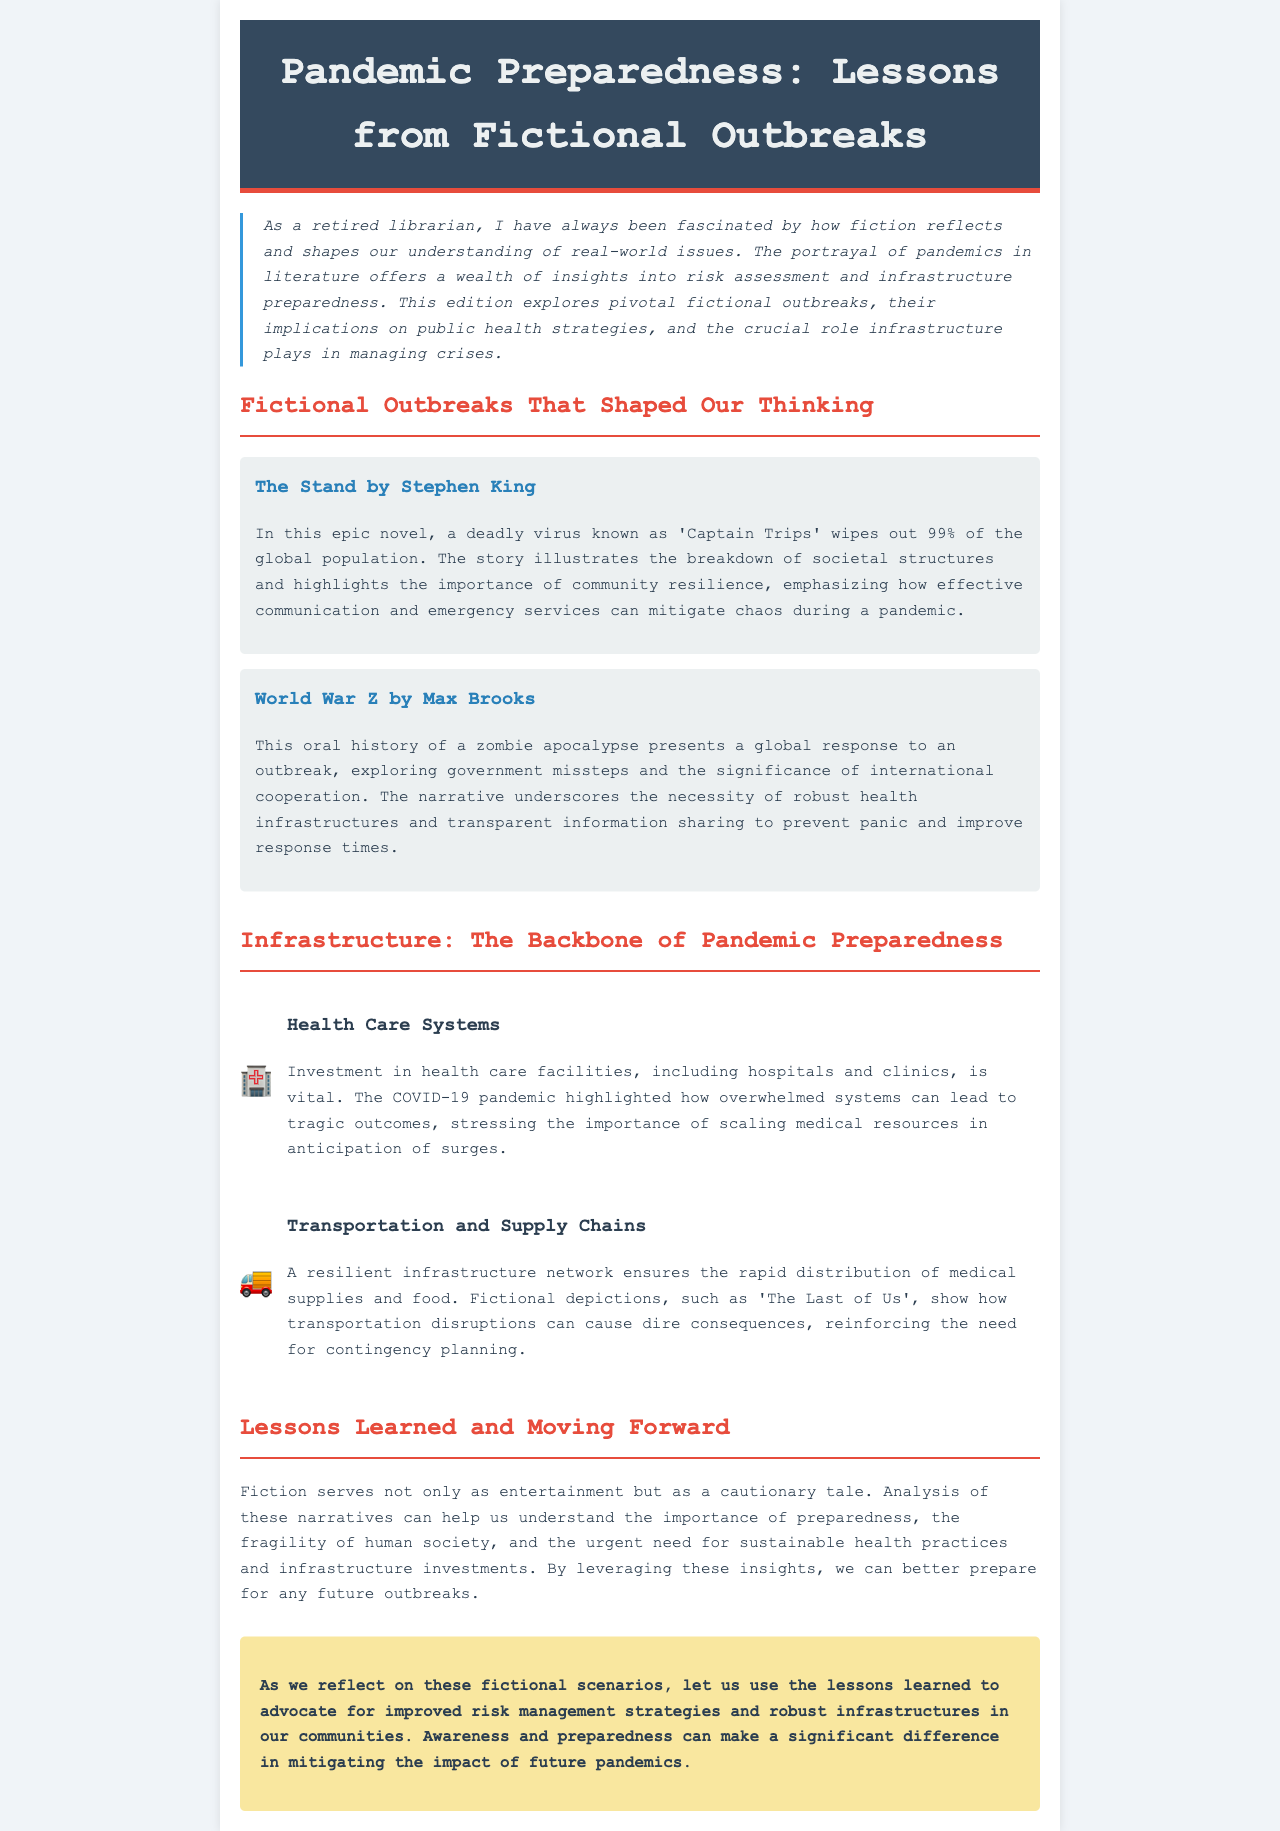what is the title of the newsletter? The title of the newsletter is provided in the header section of the document.
Answer: Pandemic Preparedness: Lessons from Fictional Outbreaks who is the author of the newsletter? The author is mentioned in the introduction as a retired librarian fascinated by fiction and its relation to real-world issues.
Answer: A retired librarian what fictional novel features 'Captain Trips'? The document lists specific fictional works discussed, including one that features 'Captain Trips'.
Answer: The Stand what is highlighted as vital for health care systems? The document discusses essential aspects needed for health care systems to manage pandemic situations.
Answer: Investment in health care facilities what fictional work is cited regarding transportation disruptions? The newsletter references a fictional narrative to illustrate the impact of transportation disruptions on pandemic preparedness.
Answer: The Last of Us what does the newsletter imply about storytelling and preparedness? The author discusses the broader implications of fictional storytelling in relation to real-world risk management and health practices.
Answer: Fiction serves as a cautionary tale which pandemic is notably mentioned in relation to overwhelmed systems? The document refers to a specific pandemic that underscored the fragility of health care systems.
Answer: COVID-19 what color scheme is used in the header of the newsletter? The header features specific colors that contribute to its overall design and branding.
Answer: Dark blue and red 